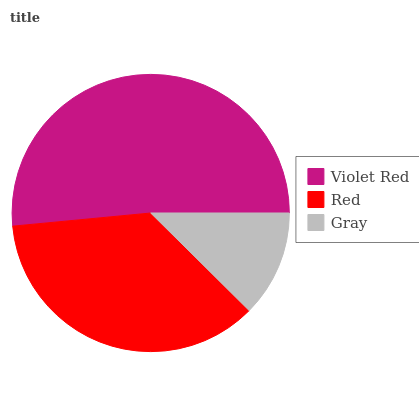Is Gray the minimum?
Answer yes or no. Yes. Is Violet Red the maximum?
Answer yes or no. Yes. Is Red the minimum?
Answer yes or no. No. Is Red the maximum?
Answer yes or no. No. Is Violet Red greater than Red?
Answer yes or no. Yes. Is Red less than Violet Red?
Answer yes or no. Yes. Is Red greater than Violet Red?
Answer yes or no. No. Is Violet Red less than Red?
Answer yes or no. No. Is Red the high median?
Answer yes or no. Yes. Is Red the low median?
Answer yes or no. Yes. Is Gray the high median?
Answer yes or no. No. Is Gray the low median?
Answer yes or no. No. 